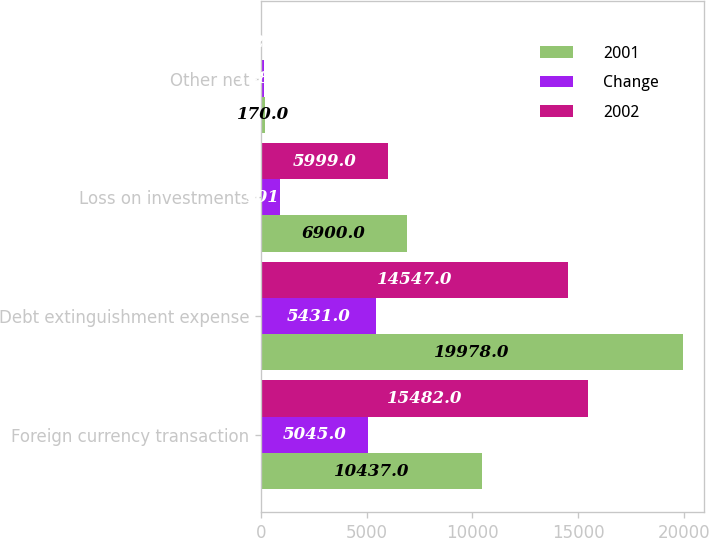Convert chart. <chart><loc_0><loc_0><loc_500><loc_500><stacked_bar_chart><ecel><fcel>Foreign currency transaction<fcel>Debt extinguishment expense<fcel>Loss on investments<fcel>Other net<nl><fcel>2001<fcel>10437<fcel>19978<fcel>6900<fcel>170<nl><fcel>Change<fcel>5045<fcel>5431<fcel>901<fcel>148<nl><fcel>2002<fcel>15482<fcel>14547<fcel>5999<fcel>22<nl></chart> 